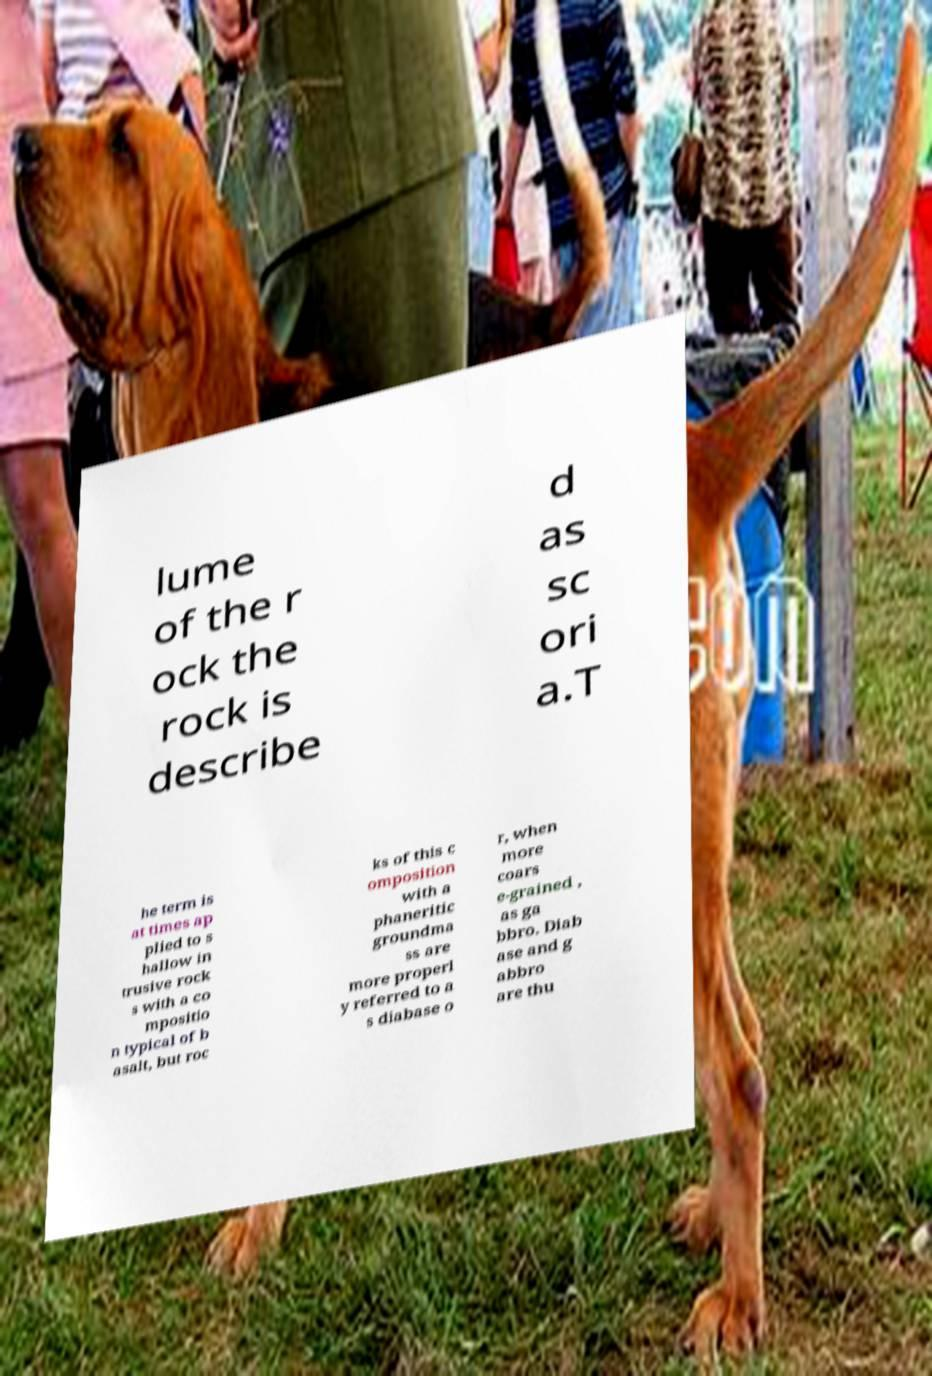Could you assist in decoding the text presented in this image and type it out clearly? lume of the r ock the rock is describe d as sc ori a.T he term is at times ap plied to s hallow in trusive rock s with a co mpositio n typical of b asalt, but roc ks of this c omposition with a phaneritic groundma ss are more properl y referred to a s diabase o r, when more coars e-grained , as ga bbro. Diab ase and g abbro are thu 